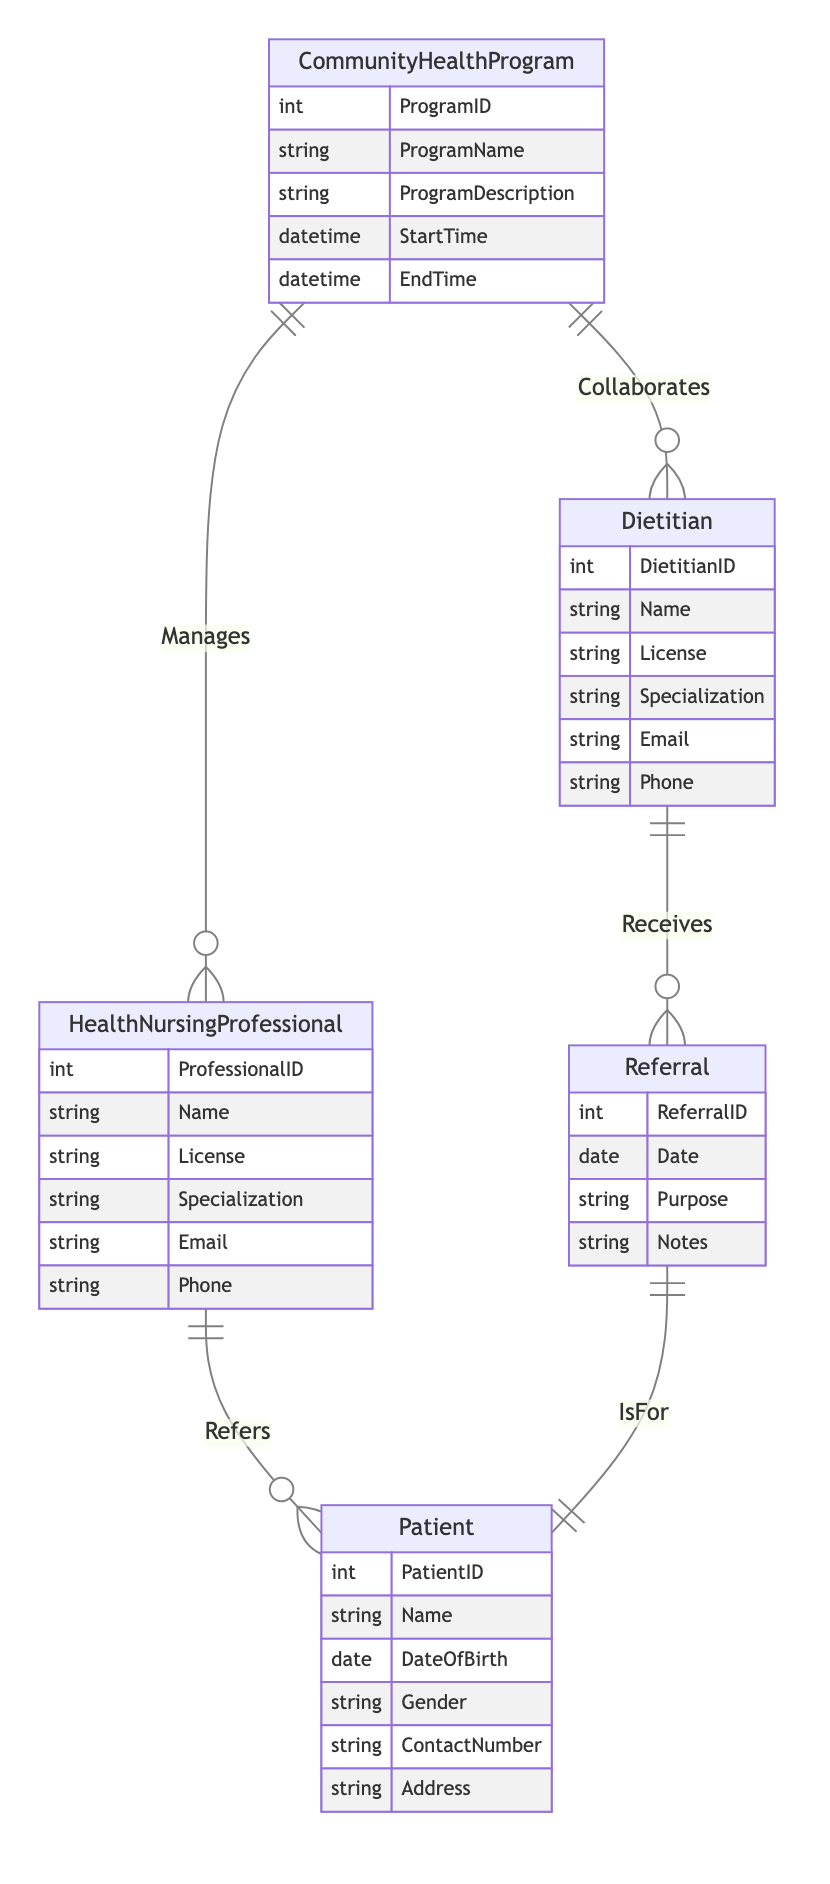What is the name of the relationship between Community Health Program and Health Nursing Professional? The relationship connecting these two entities is labeled "Manages," indicating that a Community Health Program is managed by a Health Nursing Professional.
Answer: Manages How many attributes does the Patient entity have? The Patient entity contains six attributes: PatientID, Name, DateOfBirth, Gender, ContactNumber, and Address.
Answer: Six What relationship connects Dietitian and Referral? The connection between these two entities is established by the relationship "Receives," indicating that a Dietitian receives referrals.
Answer: Receives What is the cardinality of the relationship between Referral and Patient? The relationship between Referral and Patient is defined as 1:1, meaning each Referral is associated with exactly one Patient.
Answer: One to One How many entities are involved in the diagram? The diagram contains five entities: Community Health Program, Health Nursing Professional, Patient, Dietitian, and Referral.
Answer: Five Which entity has a relationship with both Community Health Program and Patient? The defining entity with links to both Community Health Program and Patient is Health Nursing Professional, as it refers patients and manages the programs.
Answer: Health Nursing Professional What is the purpose of the Referral entity in the context of the diagram? The Referral entity serves the purpose of tracking referrals made by a Health Nursing Professional to a Dietitian for a Patient, along with information such as Date, Purpose, and Notes.
Answer: Tracking referrals What is the specialization of the Dietitian? The specialization of the Dietitian is represented as a generic attribute in the diagram, which means it can vary by individual communication, but is designated as an attribute within the Dietitian entity.
Answer: Specialization What entity does the Community Health Program collaborate with? The Community Health Program collaborates with the Dietitian, as indicated by the relationship labeled "Collaborates."
Answer: Dietitian 